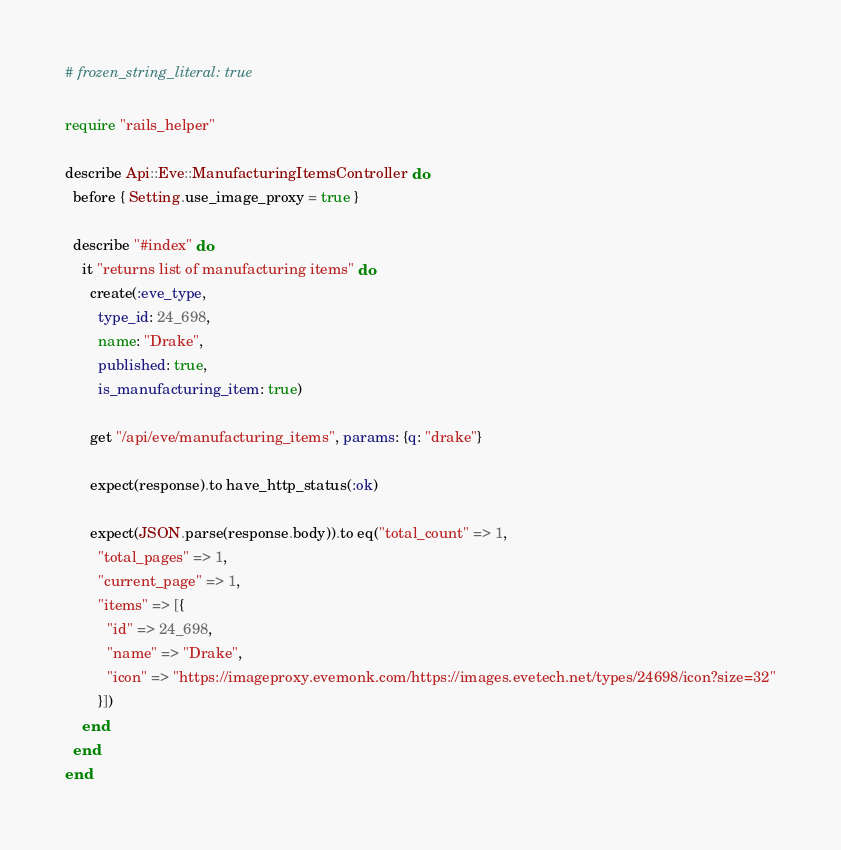<code> <loc_0><loc_0><loc_500><loc_500><_Ruby_># frozen_string_literal: true

require "rails_helper"

describe Api::Eve::ManufacturingItemsController do
  before { Setting.use_image_proxy = true }

  describe "#index" do
    it "returns list of manufacturing items" do
      create(:eve_type,
        type_id: 24_698,
        name: "Drake",
        published: true,
        is_manufacturing_item: true)

      get "/api/eve/manufacturing_items", params: {q: "drake"}

      expect(response).to have_http_status(:ok)

      expect(JSON.parse(response.body)).to eq("total_count" => 1,
        "total_pages" => 1,
        "current_page" => 1,
        "items" => [{
          "id" => 24_698,
          "name" => "Drake",
          "icon" => "https://imageproxy.evemonk.com/https://images.evetech.net/types/24698/icon?size=32"
        }])
    end
  end
end
</code> 